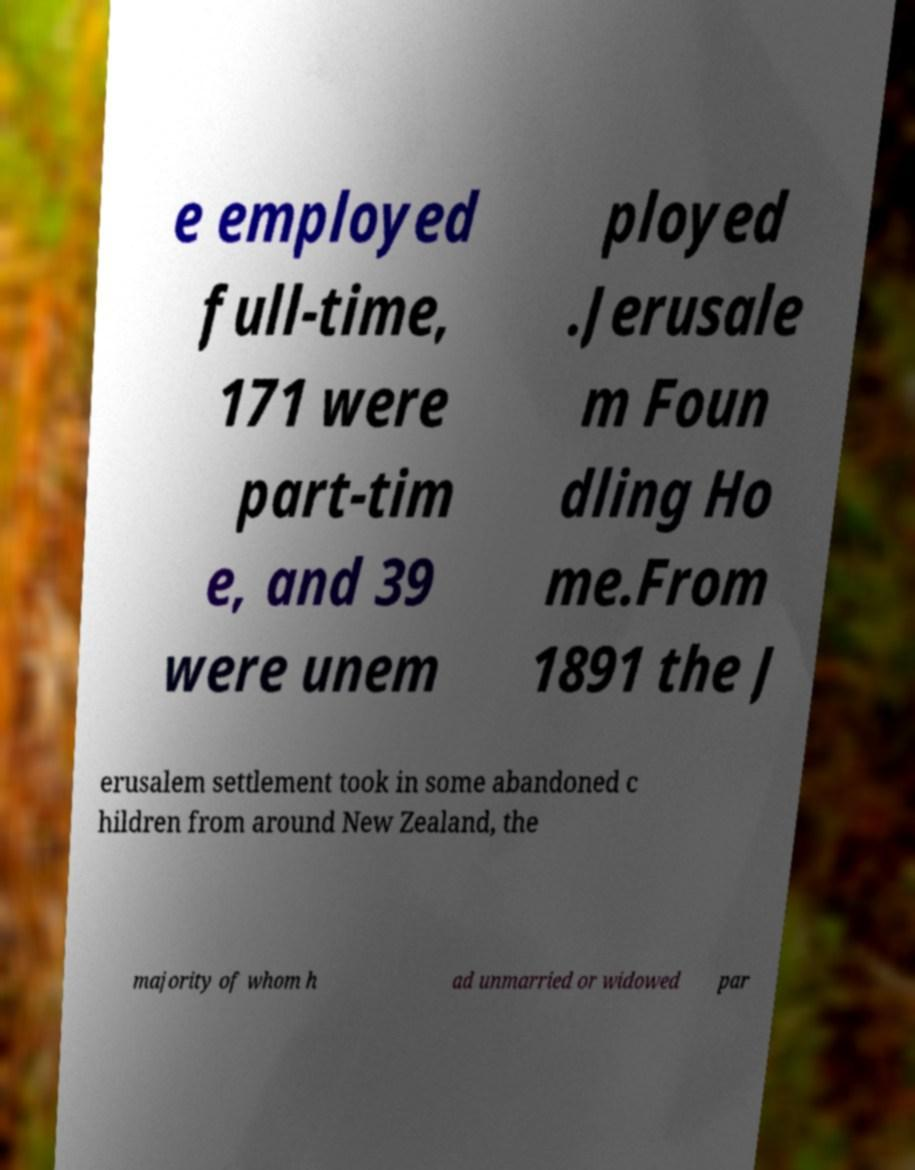Please identify and transcribe the text found in this image. e employed full-time, 171 were part-tim e, and 39 were unem ployed .Jerusale m Foun dling Ho me.From 1891 the J erusalem settlement took in some abandoned c hildren from around New Zealand, the majority of whom h ad unmarried or widowed par 